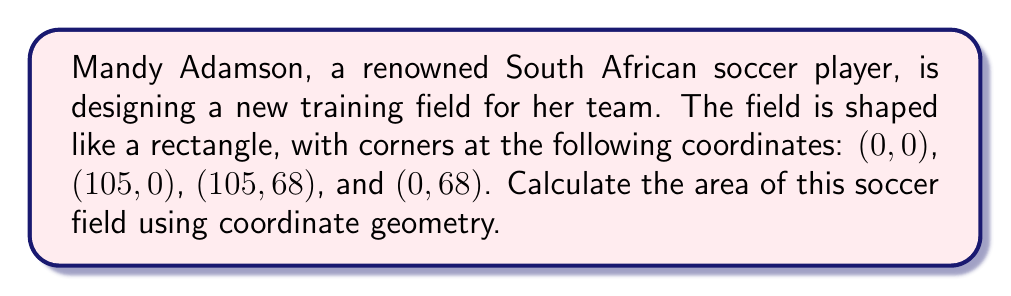Solve this math problem. To calculate the area of the soccer field using coordinate geometry, we'll follow these steps:

1) Identify the shape: The field is a rectangle.

2) Find the length and width:
   - Length: distance between (0, 0) and (105, 0)
   - Width: distance between (0, 0) and (0, 68)

3) Calculate the length:
   $l = \sqrt{(105-0)^2 + (0-0)^2} = 105$ meters

4) Calculate the width:
   $w = \sqrt{(0-0)^2 + (68-0)^2} = 68$ meters

5) Apply the area formula for a rectangle:
   $$A = l \times w$$
   $$A = 105 \times 68 = 7,140$$

Therefore, the area of the soccer field is 7,140 square meters.

[asy]
import geometry;

size(200);
draw((0,0)--(105,0)--(105,68)--(0,68)--cycle);
label("(0,0)", (0,0), SW);
label("(105,0)", (105,0), SE);
label("(105,68)", (105,68), NE);
label("(0,68)", (0,68), NW);
label("105 m", (52.5,0), S);
label("68 m", (105,34), E);
[/asy]
Answer: 7,140 m² 